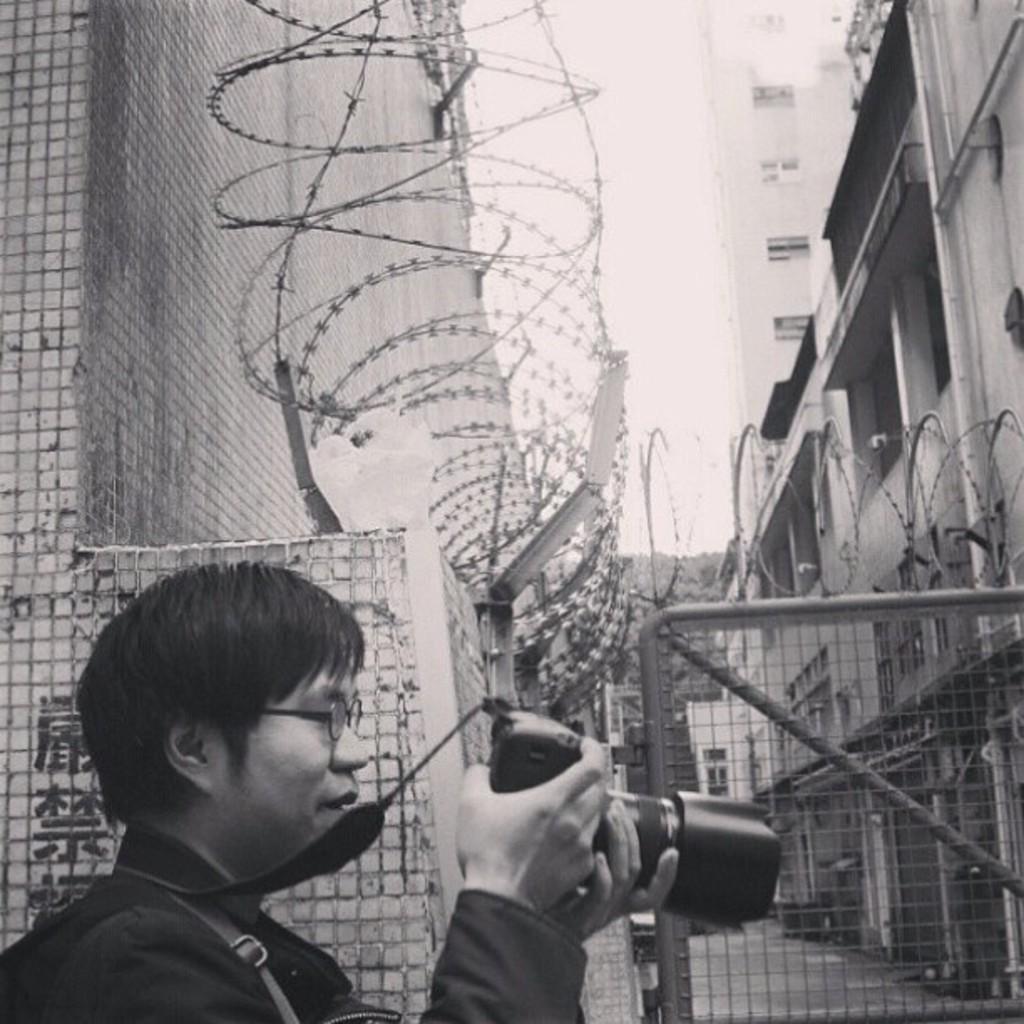Describe this image in one or two sentences. This is a black and white image and here we can see a person wearing glasses and holding a camera. In the background, there are buildings, wires and a gate with mesh. At the top, there is sky and at the bottom, there is road. 